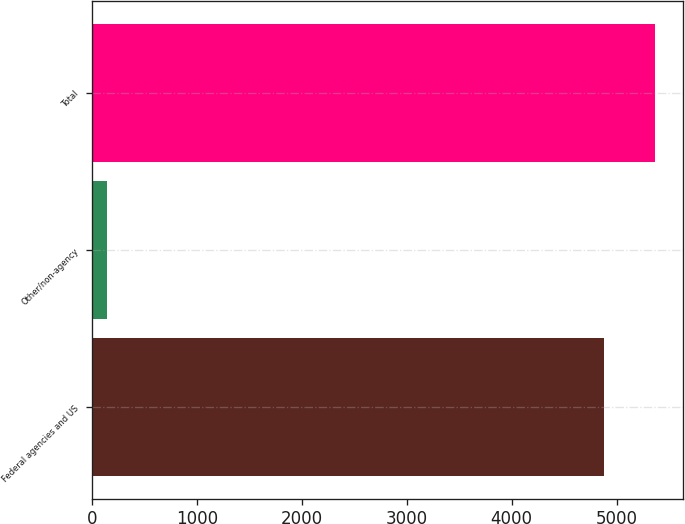Convert chart. <chart><loc_0><loc_0><loc_500><loc_500><bar_chart><fcel>Federal agencies and US<fcel>Other/non-agency<fcel>Total<nl><fcel>4881<fcel>139<fcel>5369.1<nl></chart> 